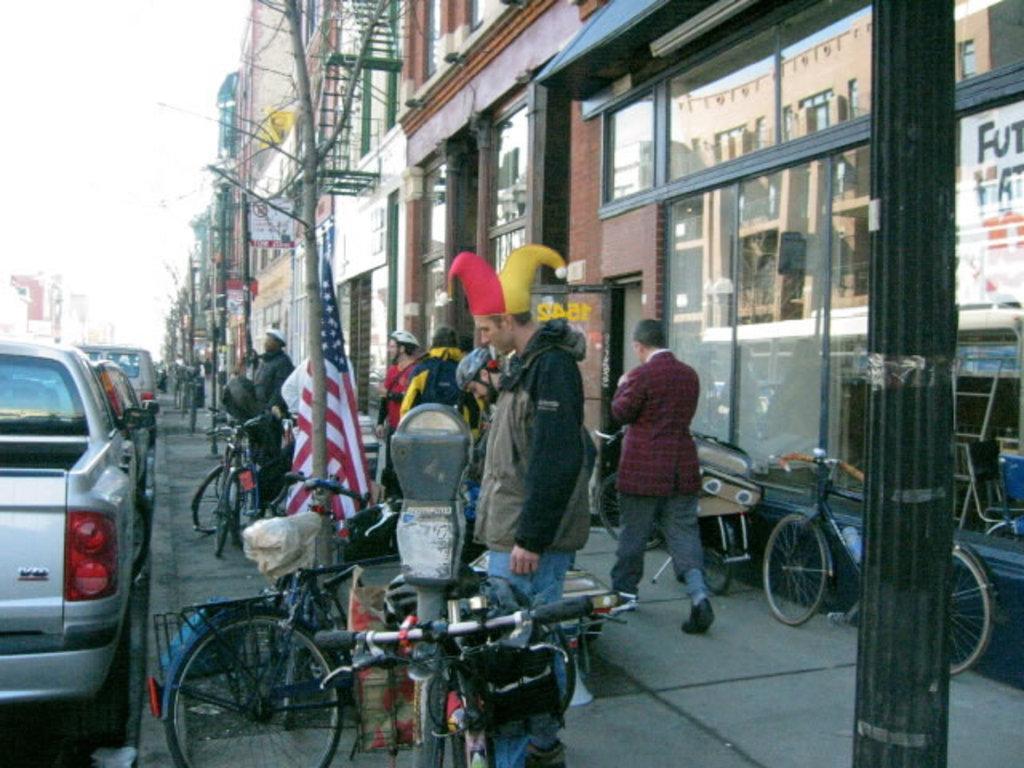Can you describe this image briefly? In this image we can see buildings, sky, motor vehicles on the road, bicycles, flag and persons standing on the floor. 